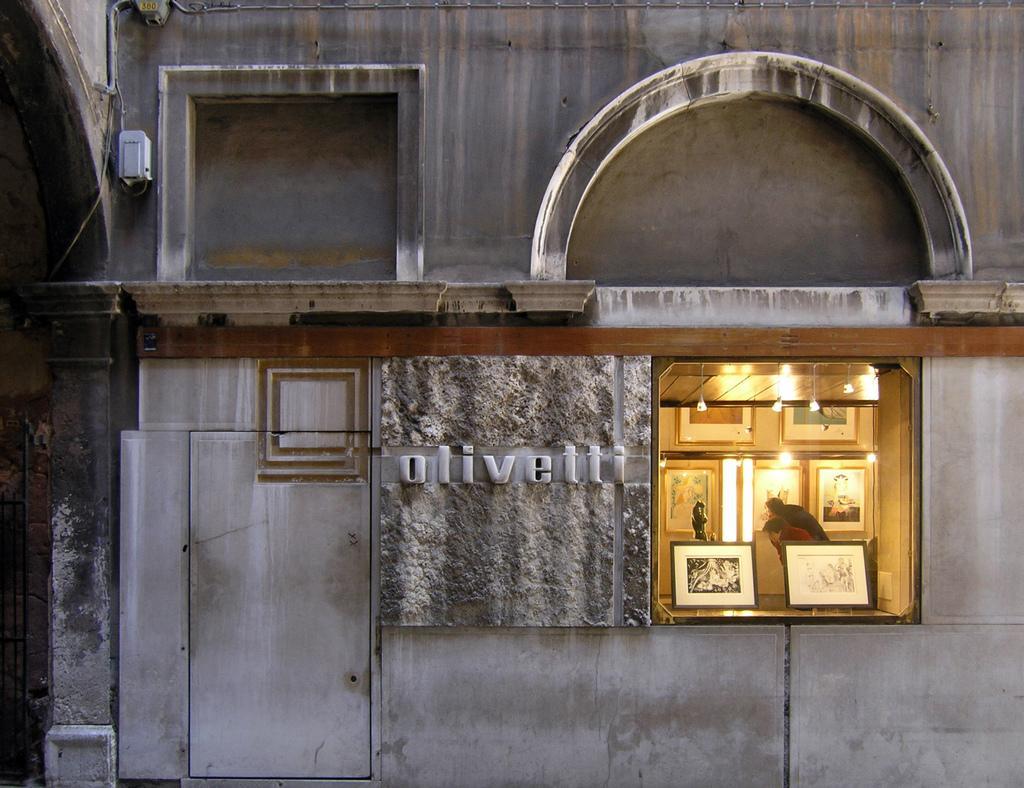How would you summarize this image in a sentence or two? In this image there is a wall, there is a man standing, there is a woman standing, there are photo frames, there are lights, there is a roof, there is text on the wall, there are objects on the wall. 